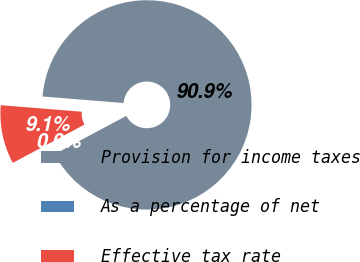<chart> <loc_0><loc_0><loc_500><loc_500><pie_chart><fcel>Provision for income taxes<fcel>As a percentage of net<fcel>Effective tax rate<nl><fcel>90.91%<fcel>0.0%<fcel>9.09%<nl></chart> 